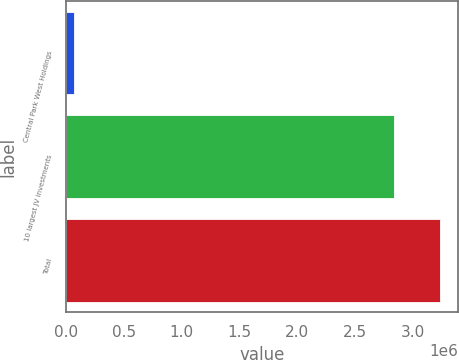Convert chart. <chart><loc_0><loc_0><loc_500><loc_500><bar_chart><fcel>Central Park West Holdings<fcel>10 largest JV investments<fcel>Total<nl><fcel>67671<fcel>2.839e+06<fcel>3.23673e+06<nl></chart> 